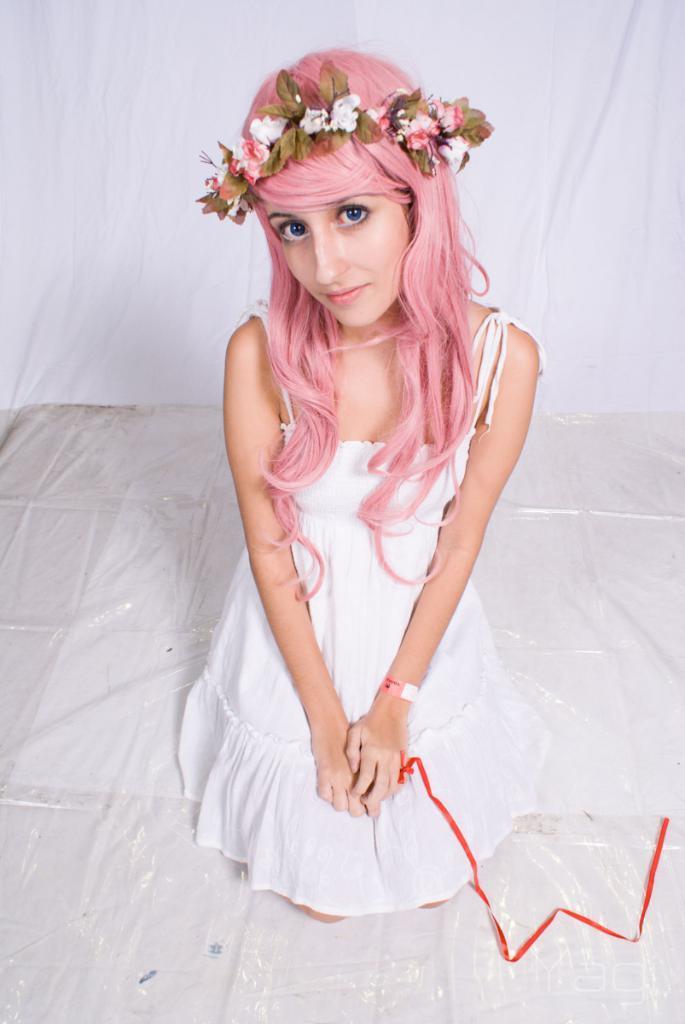Describe this image in one or two sentences. In front of the image there is a person. Behind her there is a curtain. 